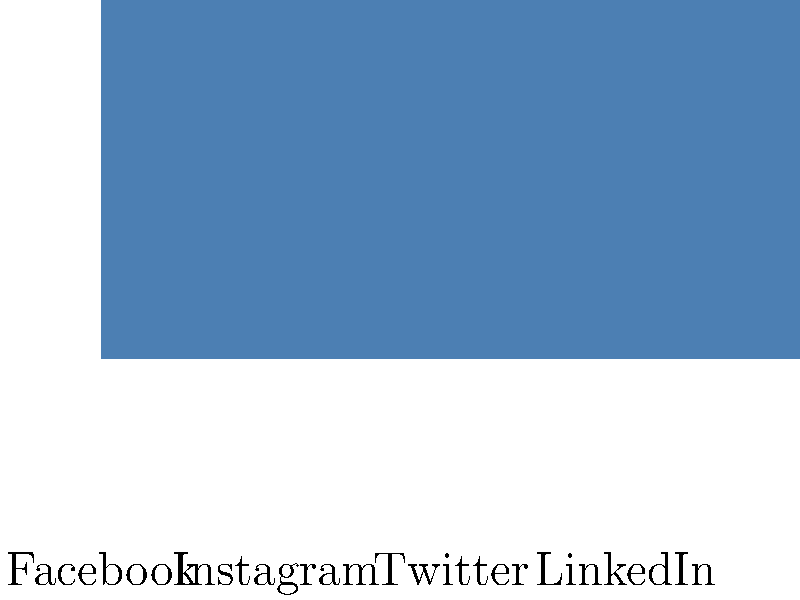Based on the bar graph showing data collection scores for different social media platforms, which platform has the highest score, indicating the most extensive data collection practices? To answer this question, we need to analyze the bar graph and compare the heights of the bars for each social media platform. The height of each bar represents the data collection score for that platform. A higher score indicates more extensive data collection practices.

Step 1: Identify the platforms represented in the graph.
The graph shows data for Facebook, Instagram, Twitter, and LinkedIn.

Step 2: Compare the heights of the bars.
Facebook: Approximately 85%
Instagram: Approximately 70%
Twitter: Approximately 60%
LinkedIn: Approximately 50%

Step 3: Determine the highest bar.
The bar for Facebook is clearly the tallest, reaching about 85% on the vertical axis.

Step 4: Interpret the result.
Since Facebook has the highest bar, it has the highest data collection score among the platforms shown.

Therefore, Facebook has the most extensive data collection practices according to this graph.
Answer: Facebook 